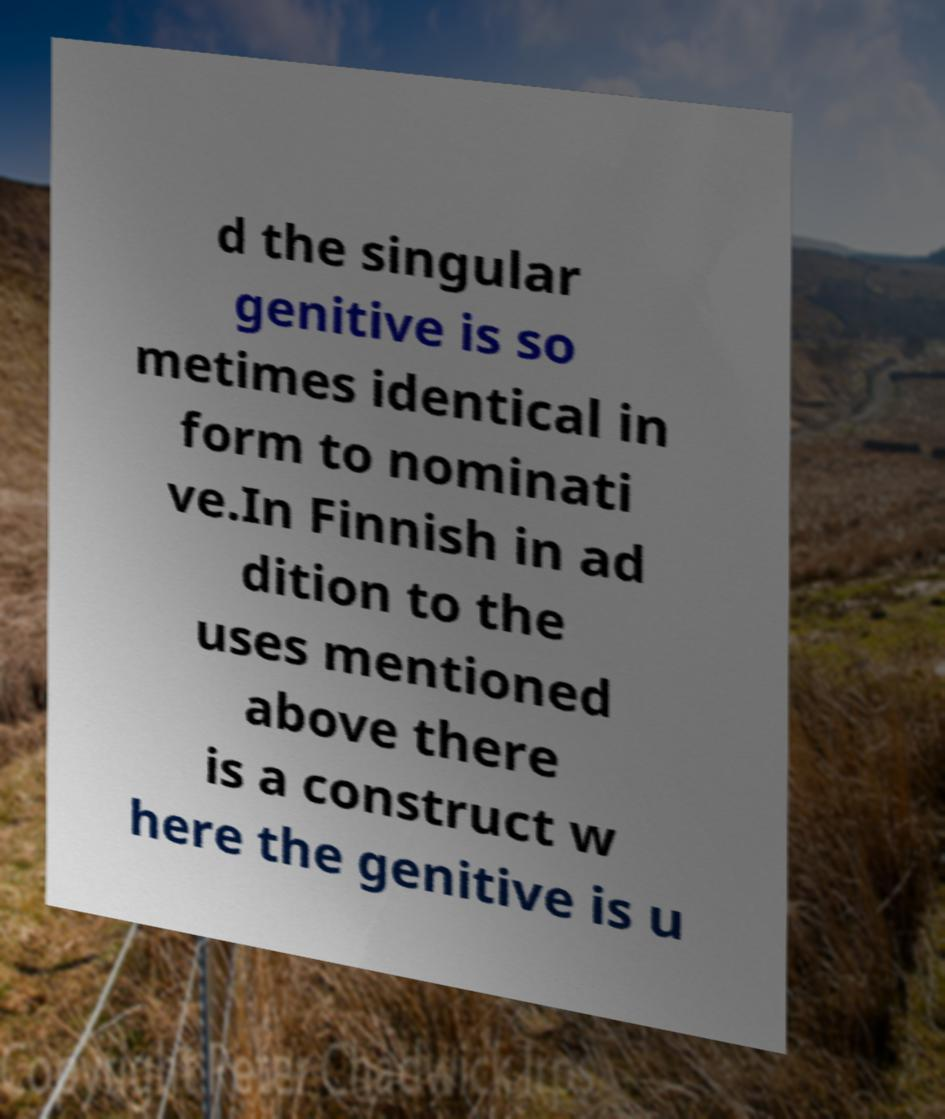There's text embedded in this image that I need extracted. Can you transcribe it verbatim? d the singular genitive is so metimes identical in form to nominati ve.In Finnish in ad dition to the uses mentioned above there is a construct w here the genitive is u 